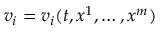<formula> <loc_0><loc_0><loc_500><loc_500>v _ { i } = v _ { i } ( t , x ^ { 1 } , \dots , x ^ { m } )</formula> 